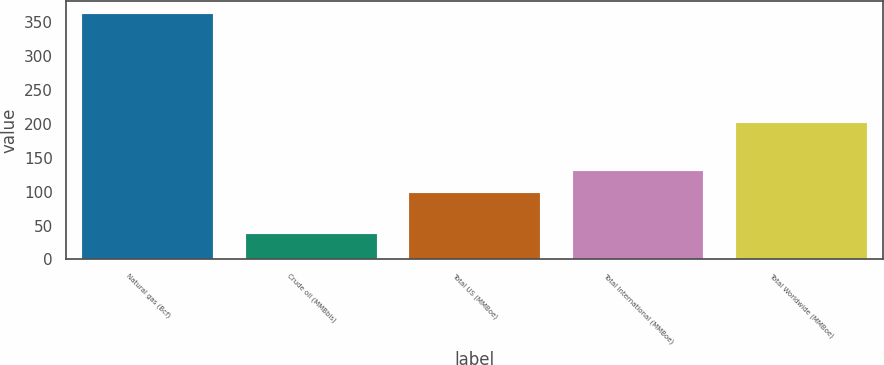Convert chart. <chart><loc_0><loc_0><loc_500><loc_500><bar_chart><fcel>Natural gas (Bcf)<fcel>Crude oil (MMBbls)<fcel>Total US (MMBoe)<fcel>Total International (MMBoe)<fcel>Total Worldwide (MMBoe)<nl><fcel>362<fcel>38<fcel>98<fcel>130.4<fcel>201<nl></chart> 